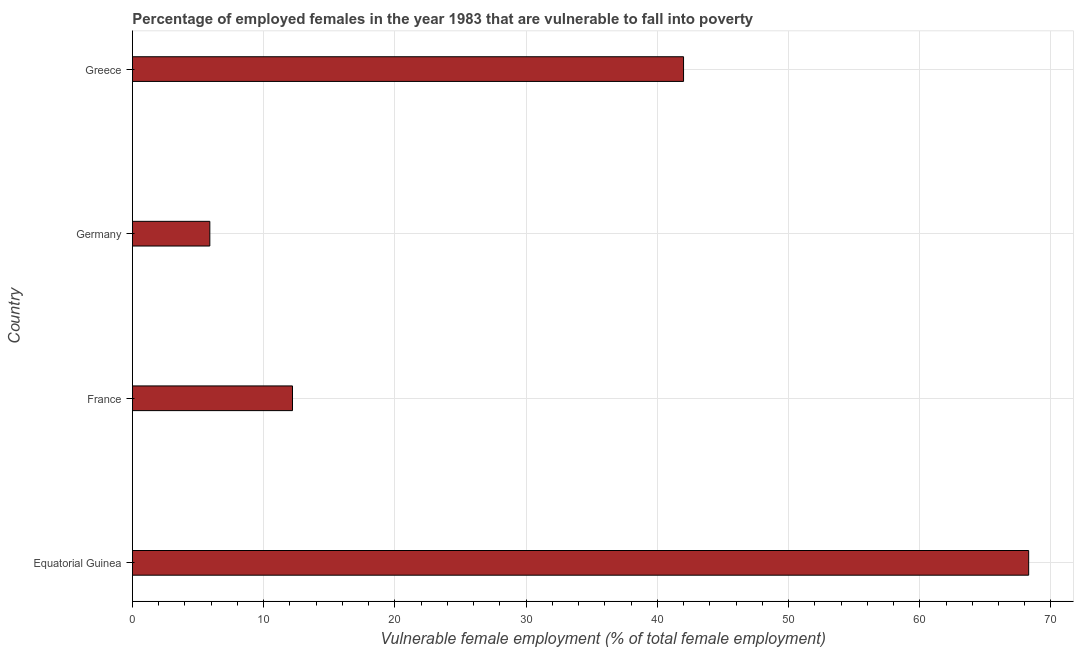What is the title of the graph?
Your answer should be very brief. Percentage of employed females in the year 1983 that are vulnerable to fall into poverty. What is the label or title of the X-axis?
Ensure brevity in your answer.  Vulnerable female employment (% of total female employment). What is the label or title of the Y-axis?
Provide a short and direct response. Country. What is the percentage of employed females who are vulnerable to fall into poverty in Greece?
Provide a short and direct response. 42. Across all countries, what is the maximum percentage of employed females who are vulnerable to fall into poverty?
Give a very brief answer. 68.3. Across all countries, what is the minimum percentage of employed females who are vulnerable to fall into poverty?
Ensure brevity in your answer.  5.9. In which country was the percentage of employed females who are vulnerable to fall into poverty maximum?
Provide a succinct answer. Equatorial Guinea. What is the sum of the percentage of employed females who are vulnerable to fall into poverty?
Your response must be concise. 128.4. What is the difference between the percentage of employed females who are vulnerable to fall into poverty in Equatorial Guinea and Greece?
Your response must be concise. 26.3. What is the average percentage of employed females who are vulnerable to fall into poverty per country?
Offer a very short reply. 32.1. What is the median percentage of employed females who are vulnerable to fall into poverty?
Your answer should be compact. 27.1. In how many countries, is the percentage of employed females who are vulnerable to fall into poverty greater than 4 %?
Give a very brief answer. 4. What is the ratio of the percentage of employed females who are vulnerable to fall into poverty in Germany to that in Greece?
Your answer should be very brief. 0.14. Is the percentage of employed females who are vulnerable to fall into poverty in France less than that in Greece?
Provide a short and direct response. Yes. What is the difference between the highest and the second highest percentage of employed females who are vulnerable to fall into poverty?
Keep it short and to the point. 26.3. What is the difference between the highest and the lowest percentage of employed females who are vulnerable to fall into poverty?
Keep it short and to the point. 62.4. In how many countries, is the percentage of employed females who are vulnerable to fall into poverty greater than the average percentage of employed females who are vulnerable to fall into poverty taken over all countries?
Your answer should be compact. 2. How many bars are there?
Provide a short and direct response. 4. Are all the bars in the graph horizontal?
Your response must be concise. Yes. How many countries are there in the graph?
Provide a short and direct response. 4. Are the values on the major ticks of X-axis written in scientific E-notation?
Give a very brief answer. No. What is the Vulnerable female employment (% of total female employment) in Equatorial Guinea?
Your answer should be very brief. 68.3. What is the Vulnerable female employment (% of total female employment) of France?
Offer a very short reply. 12.2. What is the Vulnerable female employment (% of total female employment) of Germany?
Give a very brief answer. 5.9. What is the difference between the Vulnerable female employment (% of total female employment) in Equatorial Guinea and France?
Offer a terse response. 56.1. What is the difference between the Vulnerable female employment (% of total female employment) in Equatorial Guinea and Germany?
Your response must be concise. 62.4. What is the difference between the Vulnerable female employment (% of total female employment) in Equatorial Guinea and Greece?
Ensure brevity in your answer.  26.3. What is the difference between the Vulnerable female employment (% of total female employment) in France and Germany?
Provide a short and direct response. 6.3. What is the difference between the Vulnerable female employment (% of total female employment) in France and Greece?
Provide a short and direct response. -29.8. What is the difference between the Vulnerable female employment (% of total female employment) in Germany and Greece?
Offer a terse response. -36.1. What is the ratio of the Vulnerable female employment (% of total female employment) in Equatorial Guinea to that in France?
Keep it short and to the point. 5.6. What is the ratio of the Vulnerable female employment (% of total female employment) in Equatorial Guinea to that in Germany?
Ensure brevity in your answer.  11.58. What is the ratio of the Vulnerable female employment (% of total female employment) in Equatorial Guinea to that in Greece?
Give a very brief answer. 1.63. What is the ratio of the Vulnerable female employment (% of total female employment) in France to that in Germany?
Offer a very short reply. 2.07. What is the ratio of the Vulnerable female employment (% of total female employment) in France to that in Greece?
Ensure brevity in your answer.  0.29. What is the ratio of the Vulnerable female employment (% of total female employment) in Germany to that in Greece?
Provide a short and direct response. 0.14. 